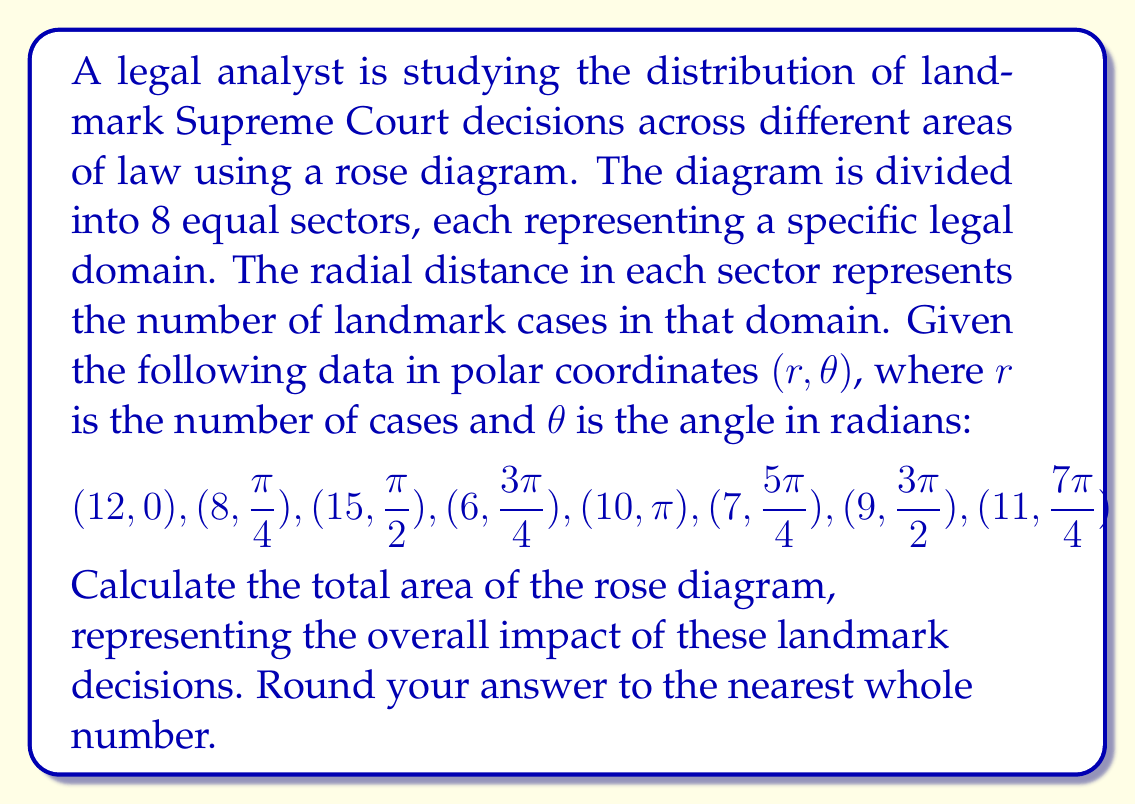Provide a solution to this math problem. To solve this problem, we need to follow these steps:

1) The area of a rose diagram is calculated by summing the areas of each sector. The area of each sector is given by the formula:

   $A_{sector} = \frac{1}{2}r^2\Delta\theta$

   where $r$ is the radial distance and $\Delta\theta$ is the angle of each sector in radians.

2) In this case, we have 8 equal sectors, so $\Delta\theta = \frac{2\pi}{8} = \frac{\pi}{4}$ radians.

3) Let's calculate the area for each sector:

   Sector 1: $A_1 = \frac{1}{2}(12^2)(\frac{\pi}{4}) = 45\pi$
   Sector 2: $A_2 = \frac{1}{2}(8^2)(\frac{\pi}{4}) = 20\pi$
   Sector 3: $A_3 = \frac{1}{2}(15^2)(\frac{\pi}{4}) = \frac{225\pi}{8}$
   Sector 4: $A_4 = \frac{1}{2}(6^2)(\frac{\pi}{4}) = \frac{9\pi}{2}$
   Sector 5: $A_5 = \frac{1}{2}(10^2)(\frac{\pi}{4}) = \frac{25\pi}{2}$
   Sector 6: $A_6 = \frac{1}{2}(7^2)(\frac{\pi}{4}) = \frac{49\pi}{8}$
   Sector 7: $A_7 = \frac{1}{2}(9^2)(\frac{\pi}{4}) = \frac{81\pi}{8}$
   Sector 8: $A_8 = \frac{1}{2}(11^2)(\frac{\pi}{4}) = \frac{121\pi}{8}$

4) The total area is the sum of all these sectors:

   $A_{total} = 45\pi + 20\pi + \frac{225\pi}{8} + \frac{9\pi}{2} + \frac{25\pi}{2} + \frac{49\pi}{8} + \frac{81\pi}{8} + \frac{121\pi}{8}$

5) Simplifying:

   $A_{total} = \pi(45 + 20 + \frac{225}{8} + \frac{9}{2} + \frac{25}{2} + \frac{49}{8} + \frac{81}{8} + \frac{121}{8})$
   
   $A_{total} = \pi(65 + \frac{225}{8} + 17 + \frac{49 + 81 + 121}{8})$
   
   $A_{total} = \pi(82 + \frac{225 + 49 + 81 + 121}{8})$
   
   $A_{total} = \pi(82 + \frac{476}{8}) = \pi(82 + 59.5) = 141.5\pi$

6) Converting to a numerical value:

   $A_{total} = 141.5 * 3.14159... \approx 444.33$

7) Rounding to the nearest whole number:

   $A_{total} \approx 444$
Answer: 444 square units 